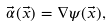<formula> <loc_0><loc_0><loc_500><loc_500>\vec { \alpha } ( \vec { x } ) = \nabla \psi ( \vec { x } ) ,</formula> 